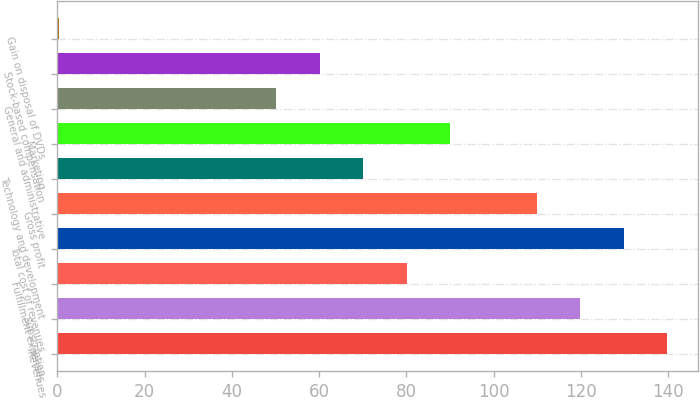Convert chart to OTSL. <chart><loc_0><loc_0><loc_500><loc_500><bar_chart><fcel>Revenues<fcel>Subscription<fcel>Fulfillment expenses<fcel>Total cost of revenues<fcel>Gross profit<fcel>Technology and development<fcel>Marketing<fcel>General and administrative<fcel>Stock-based compensation<fcel>Gain on disposal of DVDs<nl><fcel>139.84<fcel>119.92<fcel>80.08<fcel>129.88<fcel>109.96<fcel>70.12<fcel>90.04<fcel>50.2<fcel>60.16<fcel>0.4<nl></chart> 